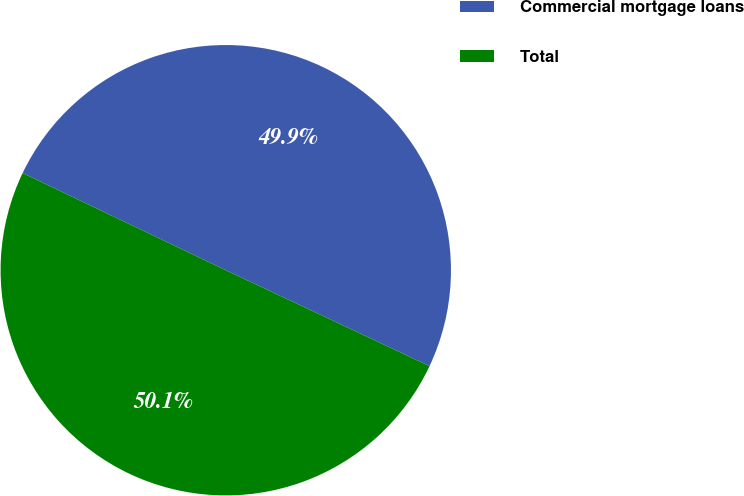<chart> <loc_0><loc_0><loc_500><loc_500><pie_chart><fcel>Commercial mortgage loans<fcel>Total<nl><fcel>49.9%<fcel>50.1%<nl></chart> 